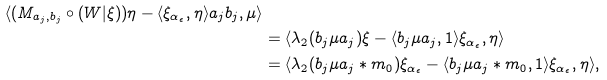Convert formula to latex. <formula><loc_0><loc_0><loc_500><loc_500>{ \langle ( M _ { a _ { j } , b _ { j } } \circ ( W | \xi ) ) \eta - \langle \xi _ { \alpha _ { \epsilon } } , \eta \rangle a _ { j } b _ { j } , \mu \rangle } \\ & = \langle \lambda _ { 2 } ( b _ { j } \mu a _ { j } ) \xi - \langle b _ { j } \mu a _ { j } , 1 \rangle \xi _ { \alpha _ { \epsilon } } , \eta \rangle \\ & = \langle \lambda _ { 2 } ( b _ { j } \mu a _ { j } \ast m _ { 0 } ) \xi _ { \alpha _ { \epsilon } } - \langle b _ { j } \mu a _ { j } \ast m _ { 0 } , 1 \rangle \xi _ { \alpha _ { \epsilon } } , \eta \rangle ,</formula> 